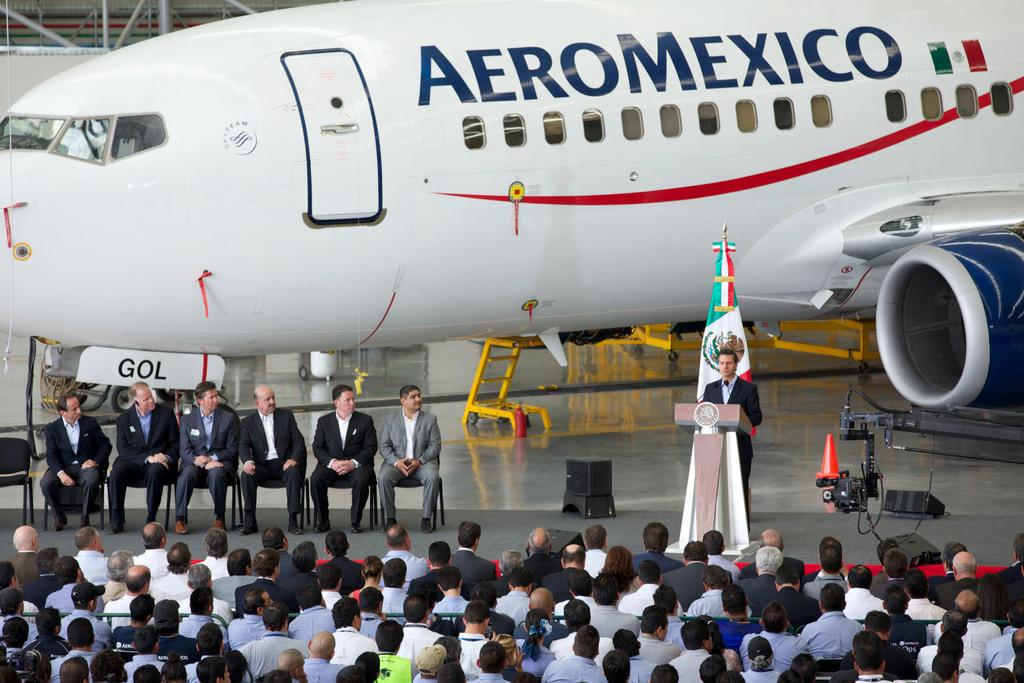Provide a one-sentence caption for the provided image. A person giving a speech in front of an airplane from the company Aero Mexico. 